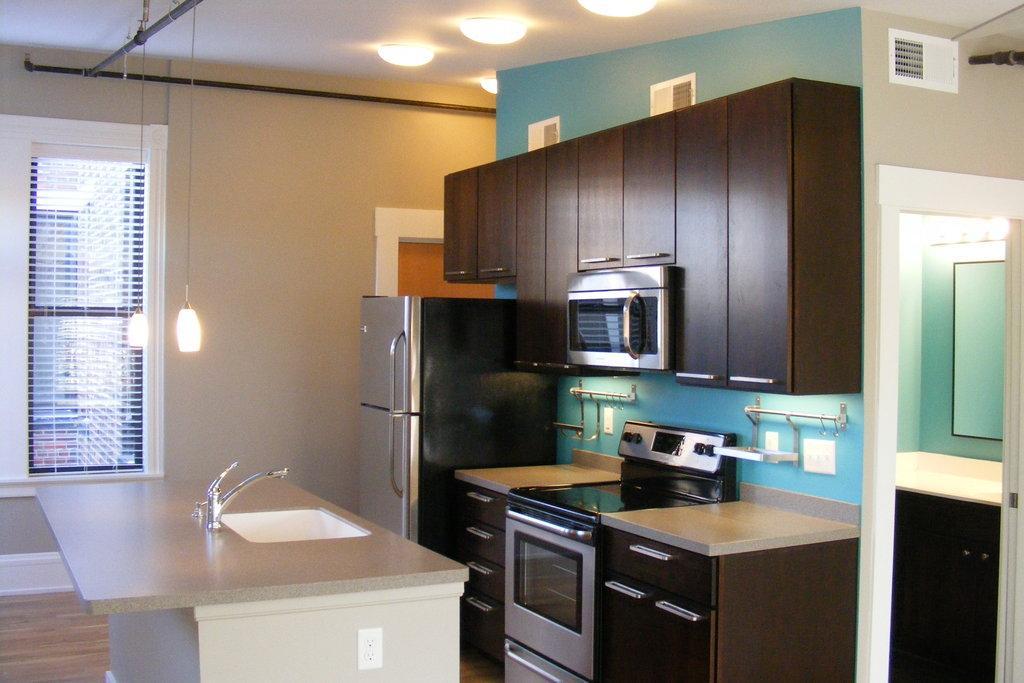Could you give a brief overview of what you see in this image? In this image we can see an interior of the house. There is a refrigerator, a table, micro oven and oven in the image. There are many lamps attached to the roof and few are hanged in the image. There is a door and window in the image. There is a tap and wash dish in the image. 